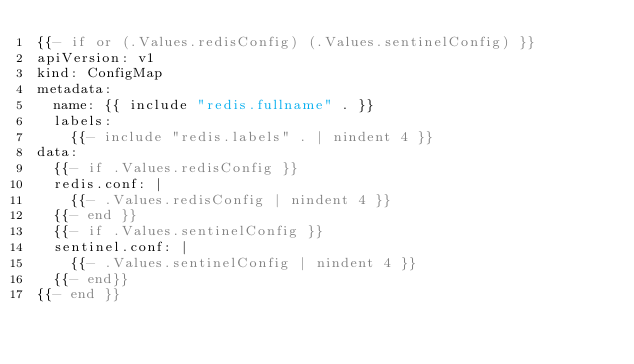<code> <loc_0><loc_0><loc_500><loc_500><_YAML_>{{- if or (.Values.redisConfig) (.Values.sentinelConfig) }}
apiVersion: v1
kind: ConfigMap
metadata:
  name: {{ include "redis.fullname" . }}
  labels:
    {{- include "redis.labels" . | nindent 4 }}
data:
  {{- if .Values.redisConfig }}
  redis.conf: |
    {{- .Values.redisConfig | nindent 4 }}
  {{- end }}
  {{- if .Values.sentinelConfig }}
  sentinel.conf: |
    {{- .Values.sentinelConfig | nindent 4 }}
  {{- end}}
{{- end }}
</code> 